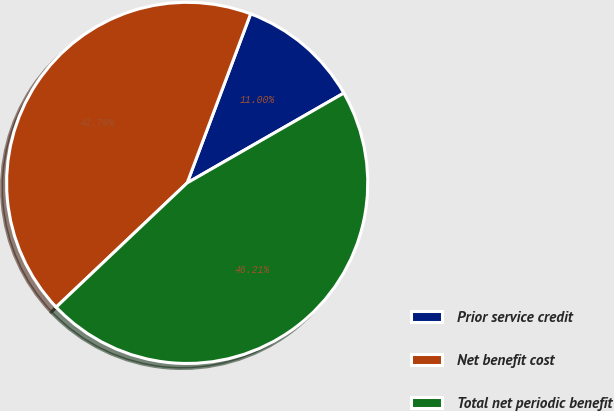Convert chart to OTSL. <chart><loc_0><loc_0><loc_500><loc_500><pie_chart><fcel>Prior service credit<fcel>Net benefit cost<fcel>Total net periodic benefit<nl><fcel>11.0%<fcel>42.79%<fcel>46.21%<nl></chart> 